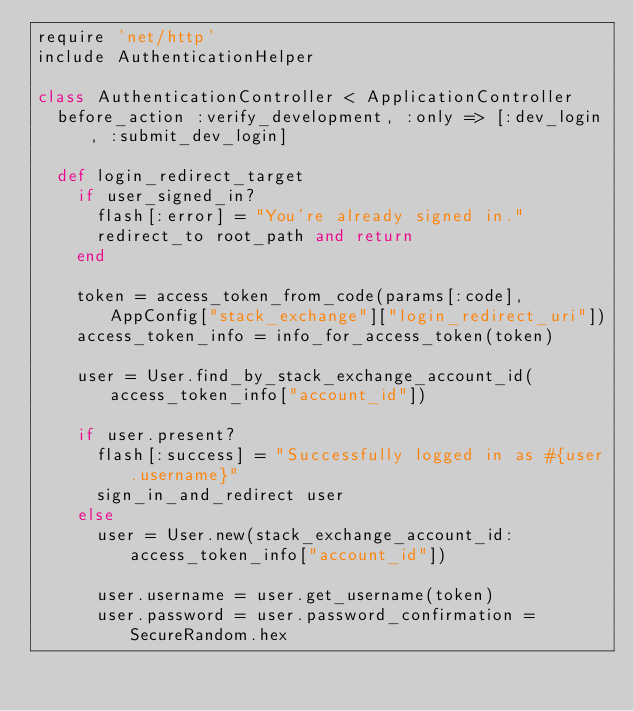<code> <loc_0><loc_0><loc_500><loc_500><_Ruby_>require 'net/http'
include AuthenticationHelper

class AuthenticationController < ApplicationController
  before_action :verify_development, :only => [:dev_login, :submit_dev_login]

  def login_redirect_target
    if user_signed_in?
      flash[:error] = "You're already signed in."
      redirect_to root_path and return
    end

    token = access_token_from_code(params[:code], AppConfig["stack_exchange"]["login_redirect_uri"])
    access_token_info = info_for_access_token(token)

    user = User.find_by_stack_exchange_account_id(access_token_info["account_id"])

    if user.present?
      flash[:success] = "Successfully logged in as #{user.username}"
      sign_in_and_redirect user
    else
      user = User.new(stack_exchange_account_id: access_token_info["account_id"])

      user.username = user.get_username(token)
      user.password = user.password_confirmation = SecureRandom.hex
</code> 